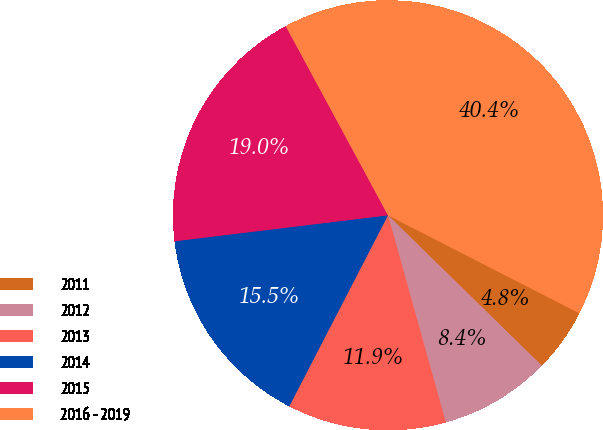<chart> <loc_0><loc_0><loc_500><loc_500><pie_chart><fcel>2011<fcel>2012<fcel>2013<fcel>2014<fcel>2015<fcel>2016 - 2019<nl><fcel>4.79%<fcel>8.35%<fcel>11.92%<fcel>15.48%<fcel>19.04%<fcel>40.41%<nl></chart> 